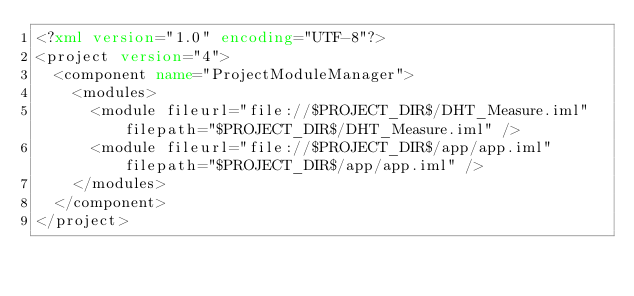Convert code to text. <code><loc_0><loc_0><loc_500><loc_500><_XML_><?xml version="1.0" encoding="UTF-8"?>
<project version="4">
  <component name="ProjectModuleManager">
    <modules>
      <module fileurl="file://$PROJECT_DIR$/DHT_Measure.iml" filepath="$PROJECT_DIR$/DHT_Measure.iml" />
      <module fileurl="file://$PROJECT_DIR$/app/app.iml" filepath="$PROJECT_DIR$/app/app.iml" />
    </modules>
  </component>
</project></code> 